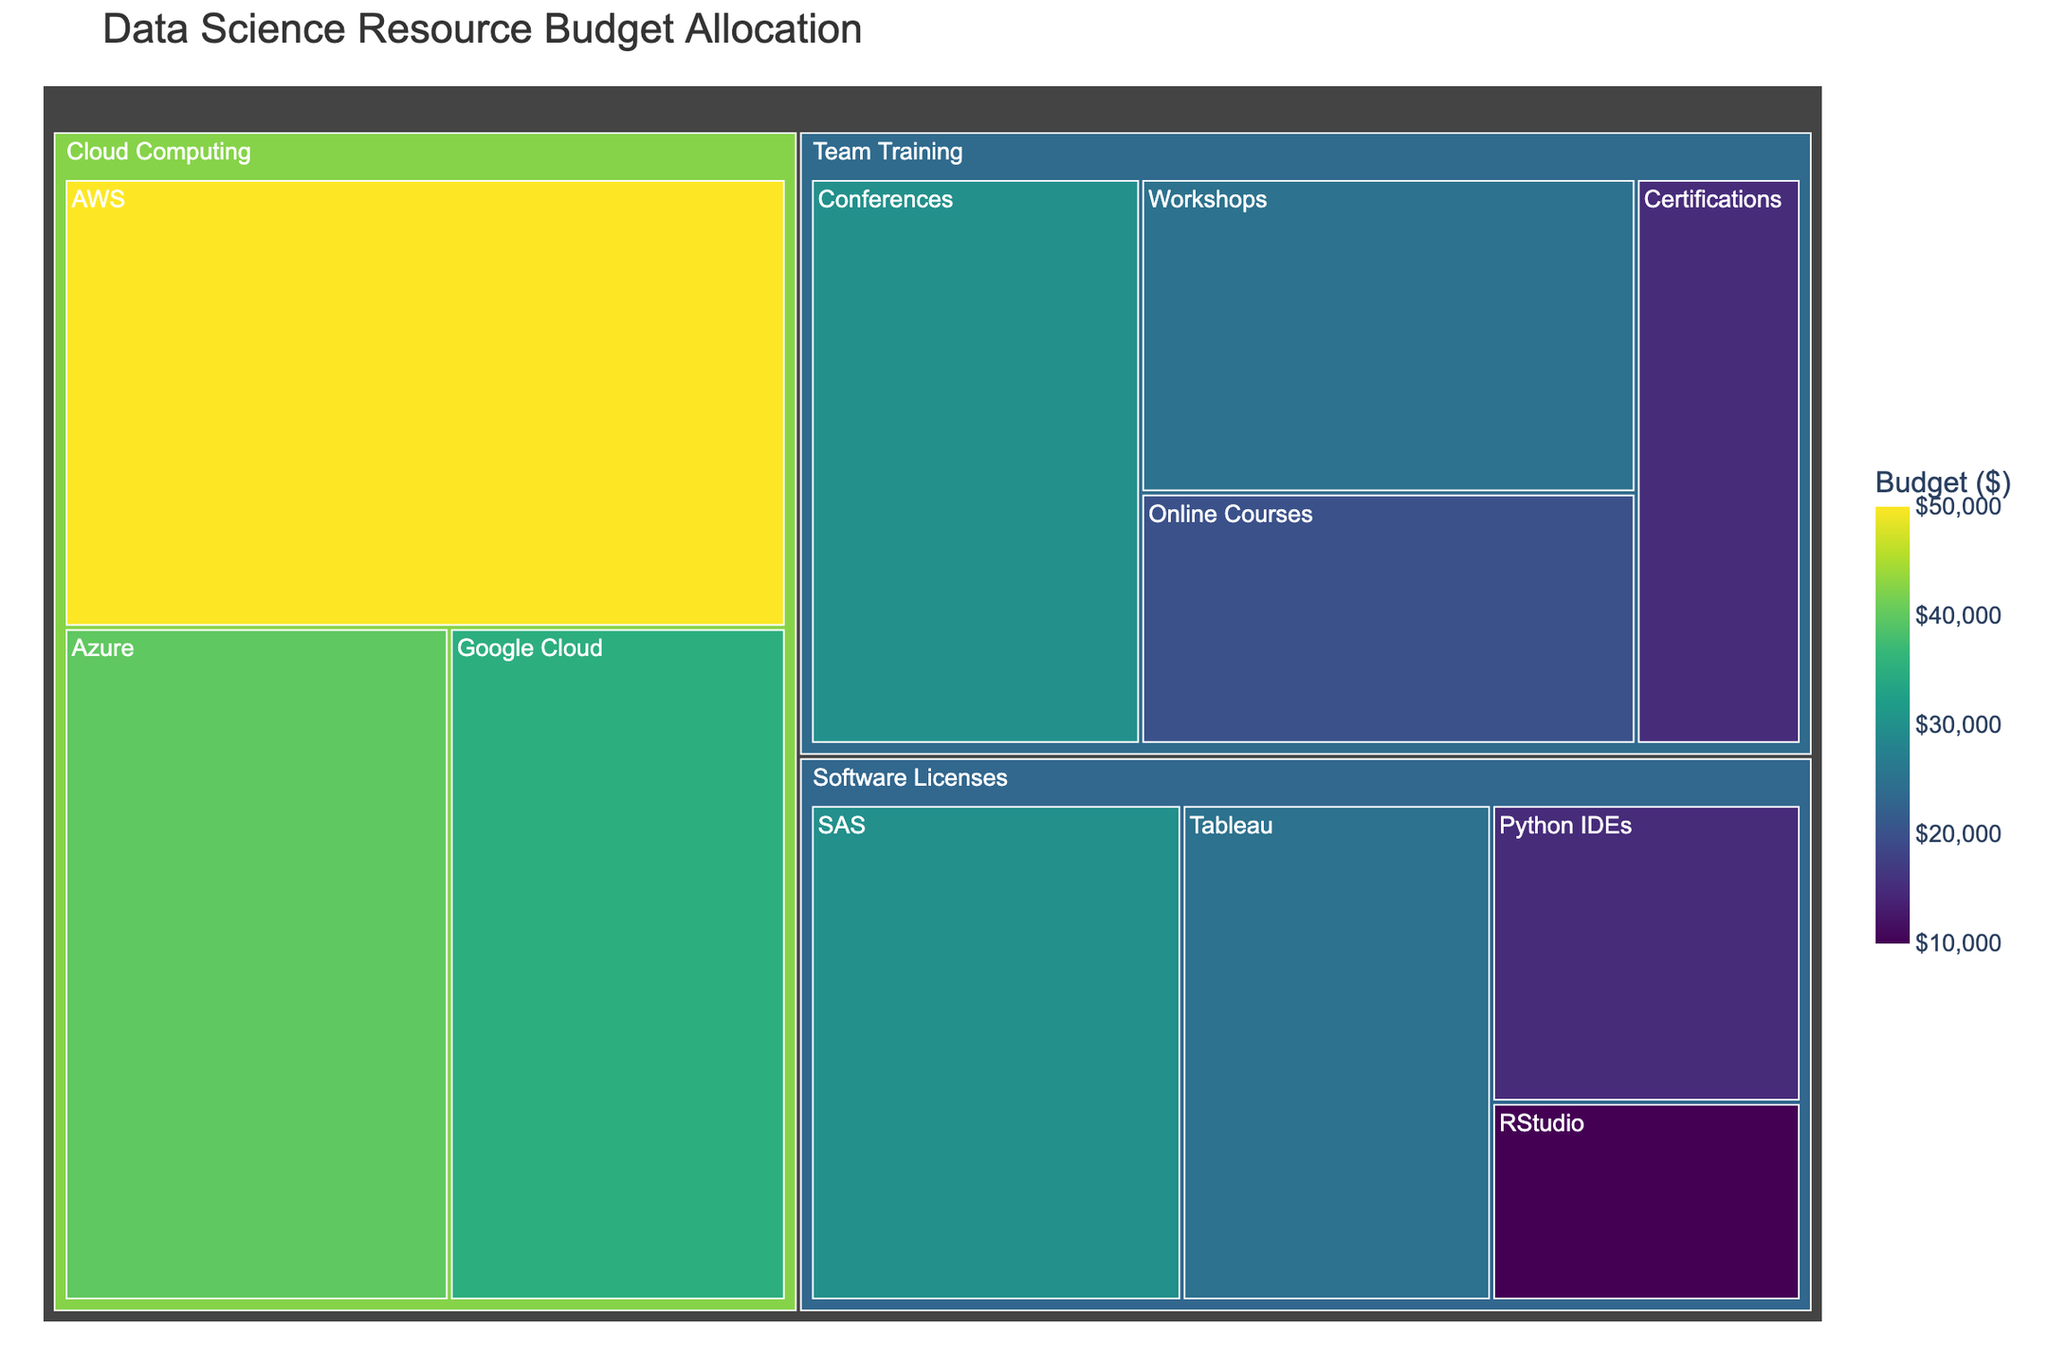What is the title of the figure? The title of the figure is usually displayed at the top of the treemap. Reading the title helps understand what the figure represents.
Answer: Data Science Resource Budget Allocation What are the main categories shown in the treemap? The treemap divides areas based on primary categories. Each large section denotes a main category.
Answer: Software Licenses, Cloud Computing, Team Training What is the total budget allocated for Software Licenses? Add the budget amounts allocated to each subcategory under the Software Licenses category. These subcategories are Tableau, Python IDEs, RStudio, and SAS. Thus, the total is $25,000 + $15,000 + $10,000 + $30,000 = $80,000.
Answer: $80,000 Which subcategory under Cloud Computing has the highest budget? Compare the budget amounts for AWS, Google Cloud, and Azure within the Cloud Computing category. AWS has $50,000, Google Cloud $35,000, and Azure $40,000.
Answer: AWS How does the budget for Team Training compare to Software Licenses? Calculate the total budget for each category: Software Licenses ($80,000) and Team Training (sum of subcategories $20,000 + $30,000 + $25,000 + $15,000 = $90,000). Compare these totals.
Answer: Team Training has a higher total budget by $10,000 What is the smallest budget allocated in the treemap, and to which subcategory does it belong? Identify the lowest budget value among all the subcategories. Python IDEs has a budget of $15,000.
Answer: Python IDEs What is the combined budget for AWS and Azure? Sum the budget amounts for AWS ($50,000) and Azure ($40,000).
Answer: $90,000 Which category has the most subcategories? Count the number of subcategories under each main category. Software Licenses, Cloud Computing, Team Training.
Answer: Team Training How does the budget for Tableau compare to the budget for Online Courses? Find the budget values for Tableau ($25,000) and Online Courses ($20,000), then compare these amounts.
Answer: Tableau has a higher budget by $5,000 What is the average budget allocated per subcategory within Cloud Computing? Determine the subcategories under Cloud Computing (AWS, Google Cloud, Azure). Sum their budgets ($50,000 + $35,000 + $40,000 = $125,000) and divide by the number of subcategories (3).
Answer: $41,667 